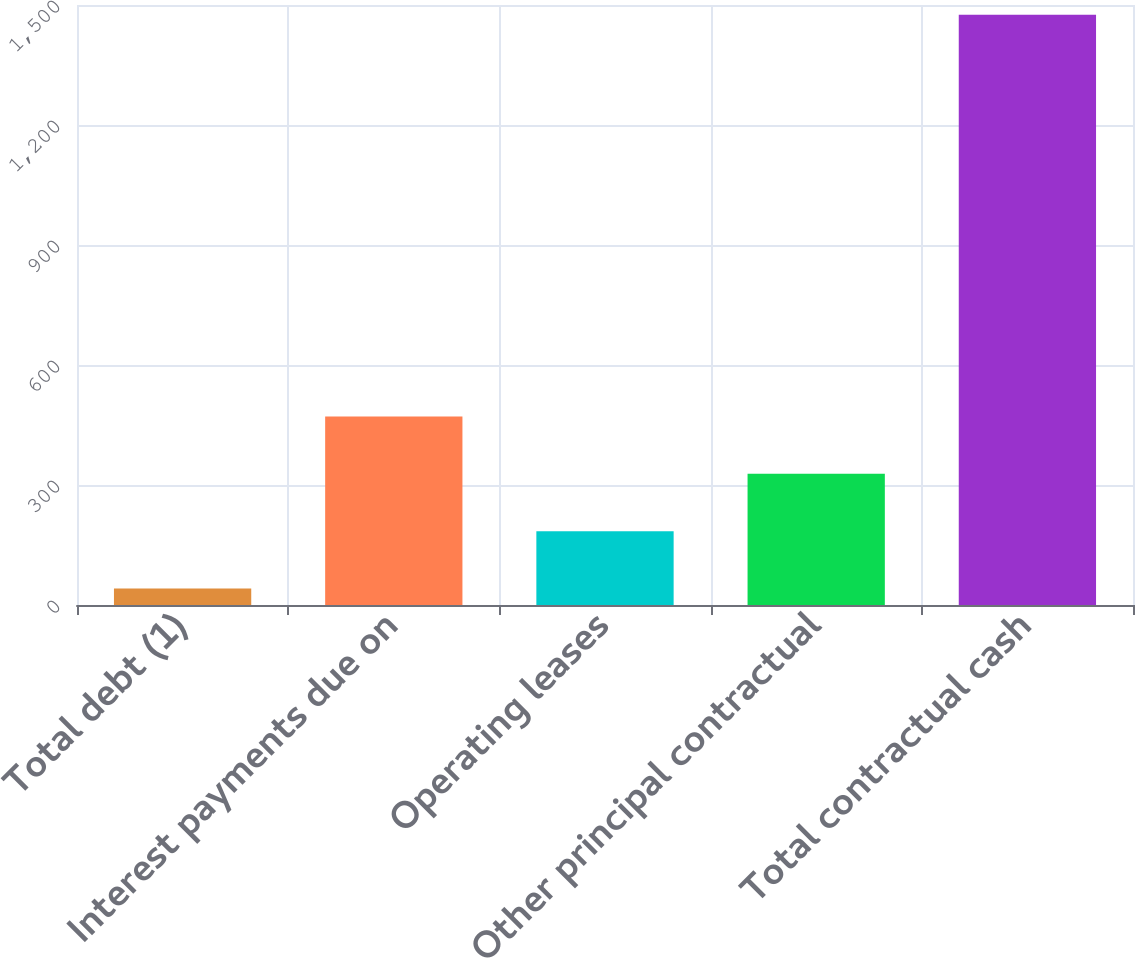Convert chart. <chart><loc_0><loc_0><loc_500><loc_500><bar_chart><fcel>Total debt (1)<fcel>Interest payments due on<fcel>Operating leases<fcel>Other principal contractual<fcel>Total contractual cash<nl><fcel>41<fcel>471.41<fcel>184.47<fcel>327.94<fcel>1475.7<nl></chart> 